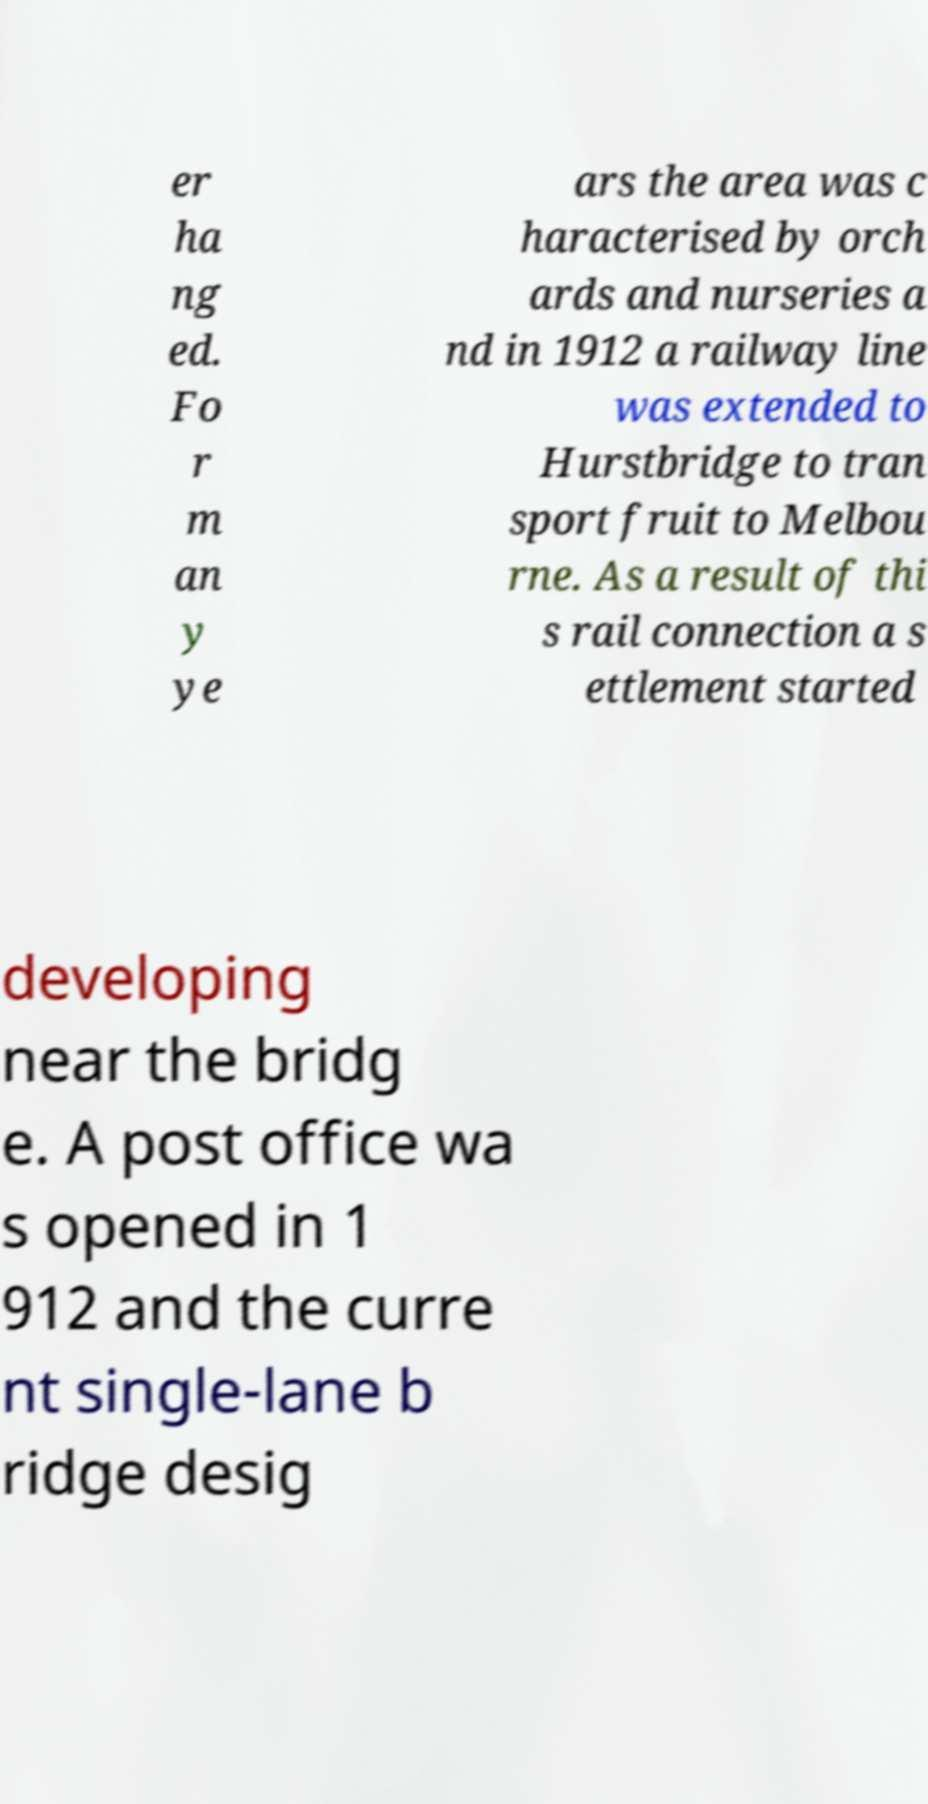What messages or text are displayed in this image? I need them in a readable, typed format. er ha ng ed. Fo r m an y ye ars the area was c haracterised by orch ards and nurseries a nd in 1912 a railway line was extended to Hurstbridge to tran sport fruit to Melbou rne. As a result of thi s rail connection a s ettlement started developing near the bridg e. A post office wa s opened in 1 912 and the curre nt single-lane b ridge desig 